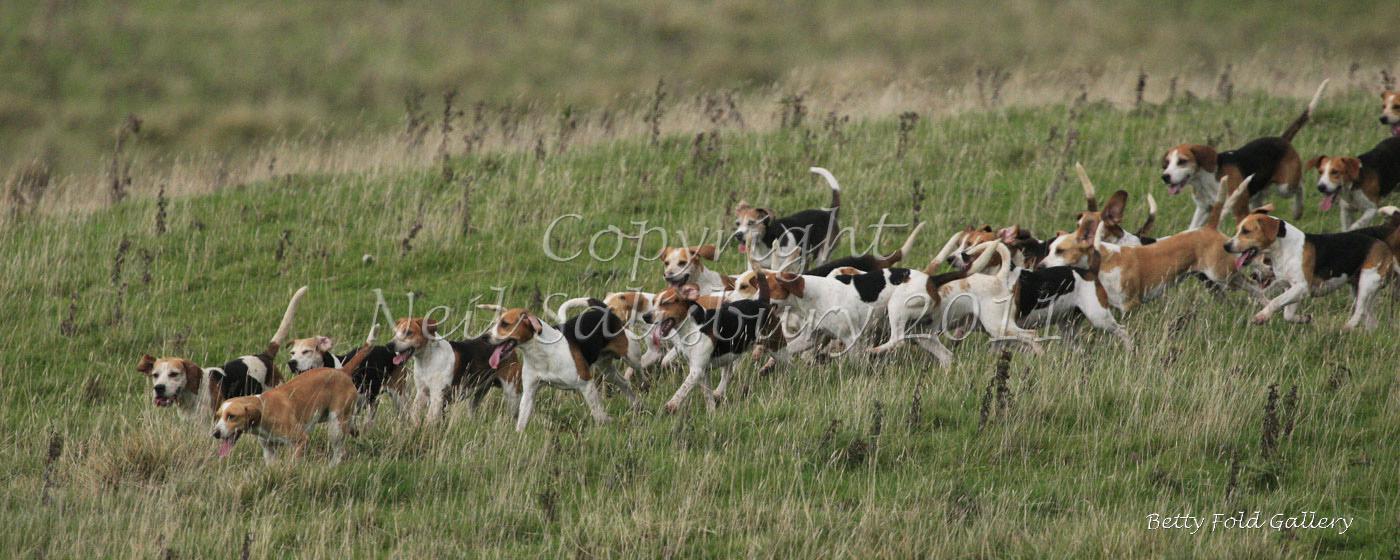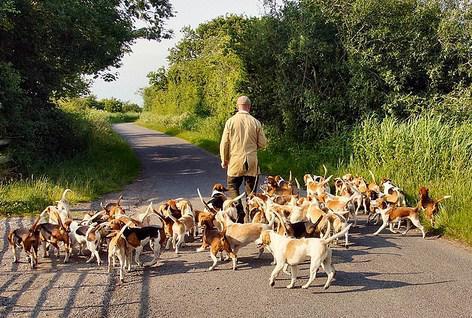The first image is the image on the left, the second image is the image on the right. Assess this claim about the two images: "A person is on the road with some of the dogs.". Correct or not? Answer yes or no. Yes. The first image is the image on the left, the second image is the image on the right. Examine the images to the left and right. Is the description "There is at least one human interacting with a pack of dogs." accurate? Answer yes or no. Yes. 